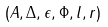<formula> <loc_0><loc_0><loc_500><loc_500>( A , \Delta , \epsilon , \Phi , l , r )</formula> 